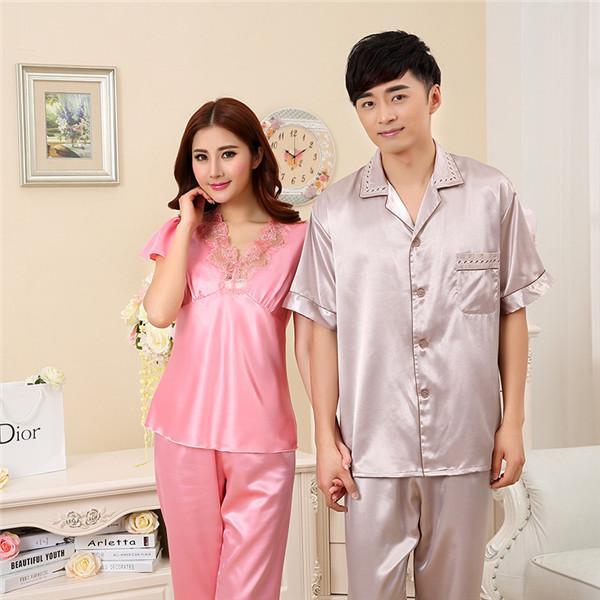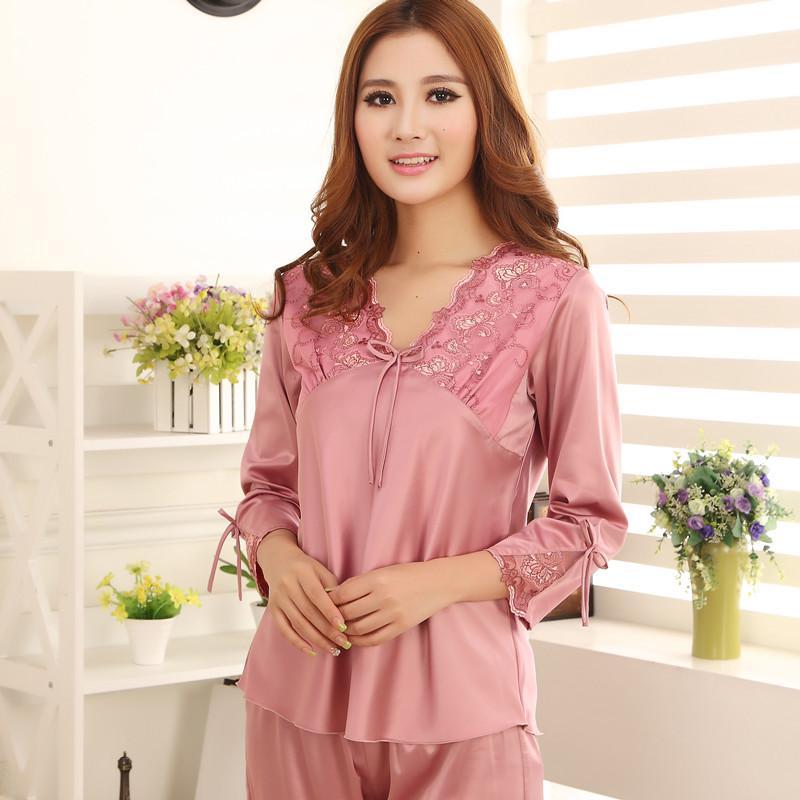The first image is the image on the left, the second image is the image on the right. Given the left and right images, does the statement "there is a woman in long sleeved pink pajamas in front of a window with window blinds" hold true? Answer yes or no. Yes. The first image is the image on the left, the second image is the image on the right. For the images shown, is this caption "The combined images include three models in short gowns in pinkish pastel shades, one wearing a matching robe over the gown." true? Answer yes or no. No. 